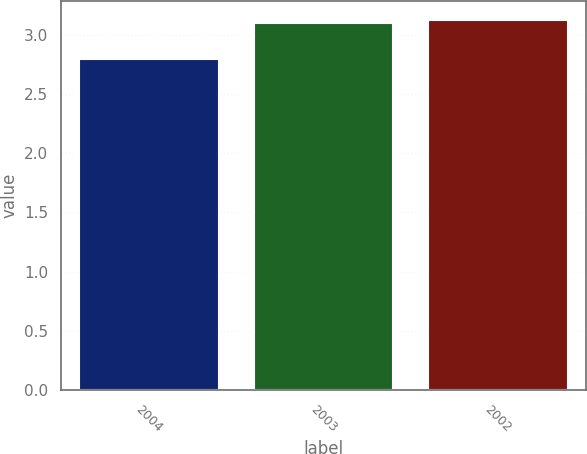<chart> <loc_0><loc_0><loc_500><loc_500><bar_chart><fcel>2004<fcel>2003<fcel>2002<nl><fcel>2.8<fcel>3.1<fcel>3.13<nl></chart> 